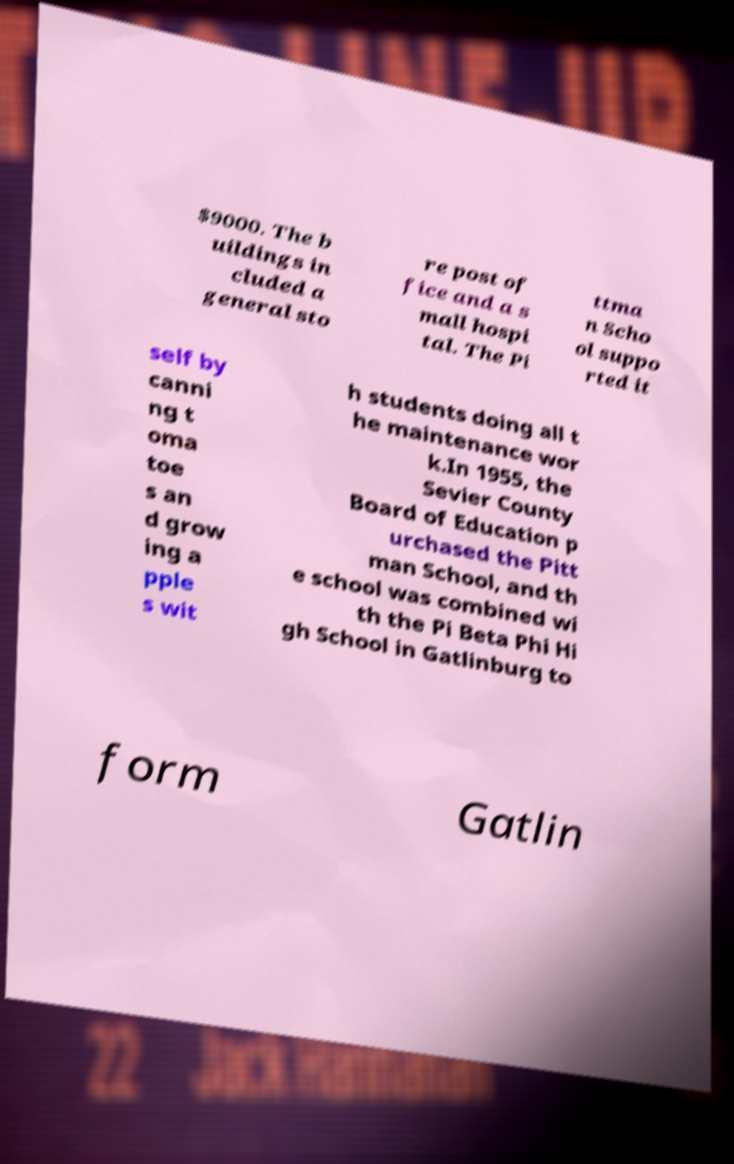I need the written content from this picture converted into text. Can you do that? $9000. The b uildings in cluded a general sto re post of fice and a s mall hospi tal. The Pi ttma n Scho ol suppo rted it self by canni ng t oma toe s an d grow ing a pple s wit h students doing all t he maintenance wor k.In 1955, the Sevier County Board of Education p urchased the Pitt man School, and th e school was combined wi th the Pi Beta Phi Hi gh School in Gatlinburg to form Gatlin 